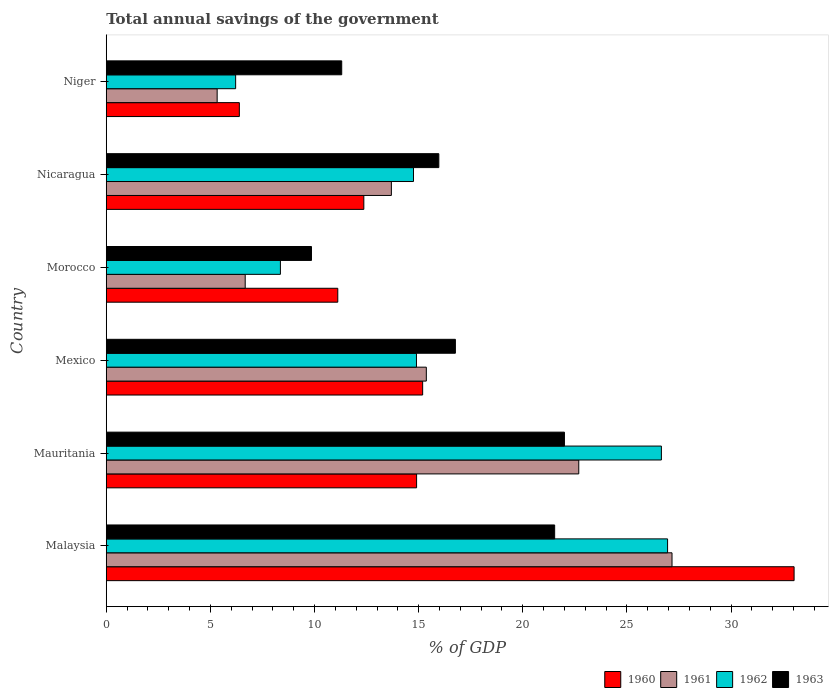How many different coloured bars are there?
Provide a succinct answer. 4. Are the number of bars per tick equal to the number of legend labels?
Make the answer very short. Yes. How many bars are there on the 4th tick from the bottom?
Offer a very short reply. 4. What is the label of the 6th group of bars from the top?
Your response must be concise. Malaysia. In how many cases, is the number of bars for a given country not equal to the number of legend labels?
Provide a short and direct response. 0. What is the total annual savings of the government in 1963 in Mexico?
Your response must be concise. 16.76. Across all countries, what is the maximum total annual savings of the government in 1963?
Offer a very short reply. 22. Across all countries, what is the minimum total annual savings of the government in 1960?
Your answer should be compact. 6.39. In which country was the total annual savings of the government in 1963 maximum?
Your answer should be very brief. Mauritania. In which country was the total annual savings of the government in 1961 minimum?
Provide a succinct answer. Niger. What is the total total annual savings of the government in 1961 in the graph?
Give a very brief answer. 90.9. What is the difference between the total annual savings of the government in 1963 in Morocco and that in Niger?
Offer a very short reply. -1.45. What is the difference between the total annual savings of the government in 1960 in Morocco and the total annual savings of the government in 1963 in Niger?
Your response must be concise. -0.19. What is the average total annual savings of the government in 1960 per country?
Offer a very short reply. 15.5. What is the difference between the total annual savings of the government in 1962 and total annual savings of the government in 1961 in Morocco?
Keep it short and to the point. 1.69. In how many countries, is the total annual savings of the government in 1963 greater than 5 %?
Your answer should be very brief. 6. What is the ratio of the total annual savings of the government in 1962 in Malaysia to that in Mauritania?
Ensure brevity in your answer.  1.01. What is the difference between the highest and the second highest total annual savings of the government in 1962?
Your answer should be very brief. 0.3. What is the difference between the highest and the lowest total annual savings of the government in 1961?
Your answer should be compact. 21.84. In how many countries, is the total annual savings of the government in 1960 greater than the average total annual savings of the government in 1960 taken over all countries?
Your response must be concise. 1. Is the sum of the total annual savings of the government in 1960 in Mauritania and Niger greater than the maximum total annual savings of the government in 1962 across all countries?
Offer a very short reply. No. What does the 4th bar from the top in Malaysia represents?
Keep it short and to the point. 1960. What does the 2nd bar from the bottom in Malaysia represents?
Provide a succinct answer. 1961. How many bars are there?
Ensure brevity in your answer.  24. Are all the bars in the graph horizontal?
Keep it short and to the point. Yes. What is the difference between two consecutive major ticks on the X-axis?
Your response must be concise. 5. Does the graph contain any zero values?
Your response must be concise. No. Does the graph contain grids?
Give a very brief answer. No. How many legend labels are there?
Make the answer very short. 4. How are the legend labels stacked?
Your response must be concise. Horizontal. What is the title of the graph?
Offer a very short reply. Total annual savings of the government. What is the label or title of the X-axis?
Offer a terse response. % of GDP. What is the label or title of the Y-axis?
Keep it short and to the point. Country. What is the % of GDP of 1960 in Malaysia?
Offer a terse response. 33.03. What is the % of GDP in 1961 in Malaysia?
Your response must be concise. 27.16. What is the % of GDP in 1962 in Malaysia?
Make the answer very short. 26.95. What is the % of GDP in 1963 in Malaysia?
Offer a terse response. 21.53. What is the % of GDP of 1960 in Mauritania?
Your answer should be very brief. 14.9. What is the % of GDP of 1961 in Mauritania?
Offer a very short reply. 22.69. What is the % of GDP of 1962 in Mauritania?
Your answer should be compact. 26.65. What is the % of GDP in 1963 in Mauritania?
Keep it short and to the point. 22. What is the % of GDP in 1960 in Mexico?
Offer a terse response. 15.19. What is the % of GDP in 1961 in Mexico?
Ensure brevity in your answer.  15.37. What is the % of GDP in 1962 in Mexico?
Keep it short and to the point. 14.89. What is the % of GDP of 1963 in Mexico?
Your answer should be compact. 16.76. What is the % of GDP of 1960 in Morocco?
Keep it short and to the point. 11.12. What is the % of GDP of 1961 in Morocco?
Give a very brief answer. 6.67. What is the % of GDP of 1962 in Morocco?
Your answer should be very brief. 8.36. What is the % of GDP of 1963 in Morocco?
Keep it short and to the point. 9.85. What is the % of GDP of 1960 in Nicaragua?
Your answer should be very brief. 12.37. What is the % of GDP in 1961 in Nicaragua?
Offer a terse response. 13.69. What is the % of GDP of 1962 in Nicaragua?
Provide a short and direct response. 14.75. What is the % of GDP in 1963 in Nicaragua?
Give a very brief answer. 15.97. What is the % of GDP in 1960 in Niger?
Offer a very short reply. 6.39. What is the % of GDP in 1961 in Niger?
Offer a terse response. 5.32. What is the % of GDP of 1962 in Niger?
Keep it short and to the point. 6.21. What is the % of GDP of 1963 in Niger?
Your answer should be very brief. 11.31. Across all countries, what is the maximum % of GDP of 1960?
Give a very brief answer. 33.03. Across all countries, what is the maximum % of GDP of 1961?
Your answer should be very brief. 27.16. Across all countries, what is the maximum % of GDP in 1962?
Offer a very short reply. 26.95. Across all countries, what is the maximum % of GDP in 1963?
Your answer should be compact. 22. Across all countries, what is the minimum % of GDP in 1960?
Make the answer very short. 6.39. Across all countries, what is the minimum % of GDP in 1961?
Make the answer very short. 5.32. Across all countries, what is the minimum % of GDP in 1962?
Offer a very short reply. 6.21. Across all countries, what is the minimum % of GDP of 1963?
Your response must be concise. 9.85. What is the total % of GDP of 1960 in the graph?
Provide a short and direct response. 92.99. What is the total % of GDP in 1961 in the graph?
Make the answer very short. 90.9. What is the total % of GDP in 1962 in the graph?
Your answer should be very brief. 97.83. What is the total % of GDP of 1963 in the graph?
Make the answer very short. 97.42. What is the difference between the % of GDP in 1960 in Malaysia and that in Mauritania?
Provide a succinct answer. 18.13. What is the difference between the % of GDP of 1961 in Malaysia and that in Mauritania?
Provide a succinct answer. 4.48. What is the difference between the % of GDP of 1962 in Malaysia and that in Mauritania?
Provide a short and direct response. 0.3. What is the difference between the % of GDP in 1963 in Malaysia and that in Mauritania?
Keep it short and to the point. -0.47. What is the difference between the % of GDP of 1960 in Malaysia and that in Mexico?
Provide a short and direct response. 17.83. What is the difference between the % of GDP in 1961 in Malaysia and that in Mexico?
Your answer should be compact. 11.8. What is the difference between the % of GDP of 1962 in Malaysia and that in Mexico?
Provide a short and direct response. 12.06. What is the difference between the % of GDP of 1963 in Malaysia and that in Mexico?
Keep it short and to the point. 4.77. What is the difference between the % of GDP of 1960 in Malaysia and that in Morocco?
Offer a very short reply. 21.91. What is the difference between the % of GDP in 1961 in Malaysia and that in Morocco?
Keep it short and to the point. 20.49. What is the difference between the % of GDP of 1962 in Malaysia and that in Morocco?
Make the answer very short. 18.59. What is the difference between the % of GDP in 1963 in Malaysia and that in Morocco?
Offer a terse response. 11.68. What is the difference between the % of GDP in 1960 in Malaysia and that in Nicaragua?
Offer a very short reply. 20.66. What is the difference between the % of GDP of 1961 in Malaysia and that in Nicaragua?
Provide a short and direct response. 13.47. What is the difference between the % of GDP of 1962 in Malaysia and that in Nicaragua?
Your answer should be very brief. 12.2. What is the difference between the % of GDP of 1963 in Malaysia and that in Nicaragua?
Keep it short and to the point. 5.56. What is the difference between the % of GDP in 1960 in Malaysia and that in Niger?
Your answer should be very brief. 26.63. What is the difference between the % of GDP of 1961 in Malaysia and that in Niger?
Ensure brevity in your answer.  21.84. What is the difference between the % of GDP in 1962 in Malaysia and that in Niger?
Your answer should be very brief. 20.74. What is the difference between the % of GDP of 1963 in Malaysia and that in Niger?
Offer a terse response. 10.22. What is the difference between the % of GDP of 1960 in Mauritania and that in Mexico?
Your response must be concise. -0.29. What is the difference between the % of GDP in 1961 in Mauritania and that in Mexico?
Provide a short and direct response. 7.32. What is the difference between the % of GDP in 1962 in Mauritania and that in Mexico?
Your response must be concise. 11.76. What is the difference between the % of GDP of 1963 in Mauritania and that in Mexico?
Make the answer very short. 5.24. What is the difference between the % of GDP in 1960 in Mauritania and that in Morocco?
Your answer should be compact. 3.78. What is the difference between the % of GDP of 1961 in Mauritania and that in Morocco?
Your answer should be very brief. 16.02. What is the difference between the % of GDP of 1962 in Mauritania and that in Morocco?
Offer a very short reply. 18.29. What is the difference between the % of GDP in 1963 in Mauritania and that in Morocco?
Offer a terse response. 12.14. What is the difference between the % of GDP of 1960 in Mauritania and that in Nicaragua?
Provide a short and direct response. 2.53. What is the difference between the % of GDP in 1961 in Mauritania and that in Nicaragua?
Ensure brevity in your answer.  9. What is the difference between the % of GDP of 1962 in Mauritania and that in Nicaragua?
Keep it short and to the point. 11.9. What is the difference between the % of GDP of 1963 in Mauritania and that in Nicaragua?
Ensure brevity in your answer.  6.03. What is the difference between the % of GDP in 1960 in Mauritania and that in Niger?
Make the answer very short. 8.51. What is the difference between the % of GDP in 1961 in Mauritania and that in Niger?
Your answer should be very brief. 17.36. What is the difference between the % of GDP in 1962 in Mauritania and that in Niger?
Provide a succinct answer. 20.44. What is the difference between the % of GDP in 1963 in Mauritania and that in Niger?
Your answer should be compact. 10.69. What is the difference between the % of GDP in 1960 in Mexico and that in Morocco?
Your response must be concise. 4.08. What is the difference between the % of GDP of 1961 in Mexico and that in Morocco?
Keep it short and to the point. 8.7. What is the difference between the % of GDP in 1962 in Mexico and that in Morocco?
Your answer should be very brief. 6.53. What is the difference between the % of GDP in 1963 in Mexico and that in Morocco?
Ensure brevity in your answer.  6.91. What is the difference between the % of GDP of 1960 in Mexico and that in Nicaragua?
Offer a very short reply. 2.82. What is the difference between the % of GDP of 1961 in Mexico and that in Nicaragua?
Keep it short and to the point. 1.68. What is the difference between the % of GDP in 1962 in Mexico and that in Nicaragua?
Give a very brief answer. 0.14. What is the difference between the % of GDP in 1963 in Mexico and that in Nicaragua?
Provide a succinct answer. 0.8. What is the difference between the % of GDP of 1960 in Mexico and that in Niger?
Offer a very short reply. 8.8. What is the difference between the % of GDP of 1961 in Mexico and that in Niger?
Keep it short and to the point. 10.04. What is the difference between the % of GDP of 1962 in Mexico and that in Niger?
Offer a terse response. 8.68. What is the difference between the % of GDP in 1963 in Mexico and that in Niger?
Offer a terse response. 5.46. What is the difference between the % of GDP in 1960 in Morocco and that in Nicaragua?
Provide a succinct answer. -1.25. What is the difference between the % of GDP in 1961 in Morocco and that in Nicaragua?
Your answer should be compact. -7.02. What is the difference between the % of GDP in 1962 in Morocco and that in Nicaragua?
Keep it short and to the point. -6.39. What is the difference between the % of GDP of 1963 in Morocco and that in Nicaragua?
Make the answer very short. -6.11. What is the difference between the % of GDP in 1960 in Morocco and that in Niger?
Offer a terse response. 4.73. What is the difference between the % of GDP in 1961 in Morocco and that in Niger?
Offer a very short reply. 1.35. What is the difference between the % of GDP of 1962 in Morocco and that in Niger?
Ensure brevity in your answer.  2.15. What is the difference between the % of GDP of 1963 in Morocco and that in Niger?
Give a very brief answer. -1.45. What is the difference between the % of GDP in 1960 in Nicaragua and that in Niger?
Offer a very short reply. 5.98. What is the difference between the % of GDP in 1961 in Nicaragua and that in Niger?
Give a very brief answer. 8.37. What is the difference between the % of GDP of 1962 in Nicaragua and that in Niger?
Your answer should be compact. 8.54. What is the difference between the % of GDP in 1963 in Nicaragua and that in Niger?
Your response must be concise. 4.66. What is the difference between the % of GDP in 1960 in Malaysia and the % of GDP in 1961 in Mauritania?
Offer a terse response. 10.34. What is the difference between the % of GDP of 1960 in Malaysia and the % of GDP of 1962 in Mauritania?
Your response must be concise. 6.37. What is the difference between the % of GDP in 1960 in Malaysia and the % of GDP in 1963 in Mauritania?
Offer a very short reply. 11.03. What is the difference between the % of GDP of 1961 in Malaysia and the % of GDP of 1962 in Mauritania?
Offer a very short reply. 0.51. What is the difference between the % of GDP of 1961 in Malaysia and the % of GDP of 1963 in Mauritania?
Give a very brief answer. 5.17. What is the difference between the % of GDP of 1962 in Malaysia and the % of GDP of 1963 in Mauritania?
Provide a short and direct response. 4.95. What is the difference between the % of GDP in 1960 in Malaysia and the % of GDP in 1961 in Mexico?
Your response must be concise. 17.66. What is the difference between the % of GDP in 1960 in Malaysia and the % of GDP in 1962 in Mexico?
Provide a succinct answer. 18.13. What is the difference between the % of GDP in 1960 in Malaysia and the % of GDP in 1963 in Mexico?
Your answer should be compact. 16.26. What is the difference between the % of GDP in 1961 in Malaysia and the % of GDP in 1962 in Mexico?
Your answer should be very brief. 12.27. What is the difference between the % of GDP of 1961 in Malaysia and the % of GDP of 1963 in Mexico?
Offer a terse response. 10.4. What is the difference between the % of GDP in 1962 in Malaysia and the % of GDP in 1963 in Mexico?
Give a very brief answer. 10.19. What is the difference between the % of GDP in 1960 in Malaysia and the % of GDP in 1961 in Morocco?
Your response must be concise. 26.35. What is the difference between the % of GDP of 1960 in Malaysia and the % of GDP of 1962 in Morocco?
Your response must be concise. 24.66. What is the difference between the % of GDP of 1960 in Malaysia and the % of GDP of 1963 in Morocco?
Your response must be concise. 23.17. What is the difference between the % of GDP of 1961 in Malaysia and the % of GDP of 1962 in Morocco?
Your response must be concise. 18.8. What is the difference between the % of GDP in 1961 in Malaysia and the % of GDP in 1963 in Morocco?
Provide a short and direct response. 17.31. What is the difference between the % of GDP in 1962 in Malaysia and the % of GDP in 1963 in Morocco?
Your answer should be very brief. 17.1. What is the difference between the % of GDP of 1960 in Malaysia and the % of GDP of 1961 in Nicaragua?
Give a very brief answer. 19.34. What is the difference between the % of GDP of 1960 in Malaysia and the % of GDP of 1962 in Nicaragua?
Provide a short and direct response. 18.27. What is the difference between the % of GDP in 1960 in Malaysia and the % of GDP in 1963 in Nicaragua?
Keep it short and to the point. 17.06. What is the difference between the % of GDP in 1961 in Malaysia and the % of GDP in 1962 in Nicaragua?
Your answer should be very brief. 12.41. What is the difference between the % of GDP in 1961 in Malaysia and the % of GDP in 1963 in Nicaragua?
Make the answer very short. 11.2. What is the difference between the % of GDP of 1962 in Malaysia and the % of GDP of 1963 in Nicaragua?
Provide a succinct answer. 10.98. What is the difference between the % of GDP of 1960 in Malaysia and the % of GDP of 1961 in Niger?
Offer a very short reply. 27.7. What is the difference between the % of GDP of 1960 in Malaysia and the % of GDP of 1962 in Niger?
Offer a terse response. 26.81. What is the difference between the % of GDP of 1960 in Malaysia and the % of GDP of 1963 in Niger?
Offer a terse response. 21.72. What is the difference between the % of GDP of 1961 in Malaysia and the % of GDP of 1962 in Niger?
Provide a succinct answer. 20.95. What is the difference between the % of GDP in 1961 in Malaysia and the % of GDP in 1963 in Niger?
Provide a short and direct response. 15.86. What is the difference between the % of GDP of 1962 in Malaysia and the % of GDP of 1963 in Niger?
Give a very brief answer. 15.65. What is the difference between the % of GDP in 1960 in Mauritania and the % of GDP in 1961 in Mexico?
Ensure brevity in your answer.  -0.47. What is the difference between the % of GDP of 1960 in Mauritania and the % of GDP of 1962 in Mexico?
Make the answer very short. 0.01. What is the difference between the % of GDP in 1960 in Mauritania and the % of GDP in 1963 in Mexico?
Ensure brevity in your answer.  -1.86. What is the difference between the % of GDP in 1961 in Mauritania and the % of GDP in 1962 in Mexico?
Keep it short and to the point. 7.79. What is the difference between the % of GDP of 1961 in Mauritania and the % of GDP of 1963 in Mexico?
Your response must be concise. 5.92. What is the difference between the % of GDP of 1962 in Mauritania and the % of GDP of 1963 in Mexico?
Your answer should be very brief. 9.89. What is the difference between the % of GDP of 1960 in Mauritania and the % of GDP of 1961 in Morocco?
Offer a terse response. 8.23. What is the difference between the % of GDP in 1960 in Mauritania and the % of GDP in 1962 in Morocco?
Ensure brevity in your answer.  6.54. What is the difference between the % of GDP of 1960 in Mauritania and the % of GDP of 1963 in Morocco?
Keep it short and to the point. 5.05. What is the difference between the % of GDP in 1961 in Mauritania and the % of GDP in 1962 in Morocco?
Ensure brevity in your answer.  14.32. What is the difference between the % of GDP in 1961 in Mauritania and the % of GDP in 1963 in Morocco?
Offer a terse response. 12.83. What is the difference between the % of GDP of 1962 in Mauritania and the % of GDP of 1963 in Morocco?
Ensure brevity in your answer.  16.8. What is the difference between the % of GDP of 1960 in Mauritania and the % of GDP of 1961 in Nicaragua?
Provide a succinct answer. 1.21. What is the difference between the % of GDP of 1960 in Mauritania and the % of GDP of 1962 in Nicaragua?
Provide a short and direct response. 0.15. What is the difference between the % of GDP in 1960 in Mauritania and the % of GDP in 1963 in Nicaragua?
Offer a terse response. -1.07. What is the difference between the % of GDP of 1961 in Mauritania and the % of GDP of 1962 in Nicaragua?
Keep it short and to the point. 7.93. What is the difference between the % of GDP of 1961 in Mauritania and the % of GDP of 1963 in Nicaragua?
Offer a very short reply. 6.72. What is the difference between the % of GDP of 1962 in Mauritania and the % of GDP of 1963 in Nicaragua?
Make the answer very short. 10.69. What is the difference between the % of GDP of 1960 in Mauritania and the % of GDP of 1961 in Niger?
Your answer should be very brief. 9.58. What is the difference between the % of GDP in 1960 in Mauritania and the % of GDP in 1962 in Niger?
Keep it short and to the point. 8.69. What is the difference between the % of GDP of 1960 in Mauritania and the % of GDP of 1963 in Niger?
Keep it short and to the point. 3.6. What is the difference between the % of GDP in 1961 in Mauritania and the % of GDP in 1962 in Niger?
Ensure brevity in your answer.  16.47. What is the difference between the % of GDP of 1961 in Mauritania and the % of GDP of 1963 in Niger?
Your answer should be compact. 11.38. What is the difference between the % of GDP of 1962 in Mauritania and the % of GDP of 1963 in Niger?
Keep it short and to the point. 15.35. What is the difference between the % of GDP of 1960 in Mexico and the % of GDP of 1961 in Morocco?
Your answer should be very brief. 8.52. What is the difference between the % of GDP of 1960 in Mexico and the % of GDP of 1962 in Morocco?
Provide a succinct answer. 6.83. What is the difference between the % of GDP in 1960 in Mexico and the % of GDP in 1963 in Morocco?
Offer a very short reply. 5.34. What is the difference between the % of GDP of 1961 in Mexico and the % of GDP of 1962 in Morocco?
Your response must be concise. 7.01. What is the difference between the % of GDP in 1961 in Mexico and the % of GDP in 1963 in Morocco?
Your answer should be compact. 5.51. What is the difference between the % of GDP in 1962 in Mexico and the % of GDP in 1963 in Morocco?
Give a very brief answer. 5.04. What is the difference between the % of GDP in 1960 in Mexico and the % of GDP in 1961 in Nicaragua?
Provide a short and direct response. 1.5. What is the difference between the % of GDP in 1960 in Mexico and the % of GDP in 1962 in Nicaragua?
Provide a short and direct response. 0.44. What is the difference between the % of GDP in 1960 in Mexico and the % of GDP in 1963 in Nicaragua?
Offer a terse response. -0.78. What is the difference between the % of GDP of 1961 in Mexico and the % of GDP of 1962 in Nicaragua?
Your answer should be very brief. 0.62. What is the difference between the % of GDP of 1961 in Mexico and the % of GDP of 1963 in Nicaragua?
Make the answer very short. -0.6. What is the difference between the % of GDP in 1962 in Mexico and the % of GDP in 1963 in Nicaragua?
Make the answer very short. -1.07. What is the difference between the % of GDP in 1960 in Mexico and the % of GDP in 1961 in Niger?
Give a very brief answer. 9.87. What is the difference between the % of GDP of 1960 in Mexico and the % of GDP of 1962 in Niger?
Your response must be concise. 8.98. What is the difference between the % of GDP in 1960 in Mexico and the % of GDP in 1963 in Niger?
Keep it short and to the point. 3.89. What is the difference between the % of GDP in 1961 in Mexico and the % of GDP in 1962 in Niger?
Your response must be concise. 9.16. What is the difference between the % of GDP of 1961 in Mexico and the % of GDP of 1963 in Niger?
Keep it short and to the point. 4.06. What is the difference between the % of GDP in 1962 in Mexico and the % of GDP in 1963 in Niger?
Offer a very short reply. 3.59. What is the difference between the % of GDP of 1960 in Morocco and the % of GDP of 1961 in Nicaragua?
Ensure brevity in your answer.  -2.57. What is the difference between the % of GDP of 1960 in Morocco and the % of GDP of 1962 in Nicaragua?
Your answer should be compact. -3.63. What is the difference between the % of GDP of 1960 in Morocco and the % of GDP of 1963 in Nicaragua?
Your answer should be compact. -4.85. What is the difference between the % of GDP in 1961 in Morocco and the % of GDP in 1962 in Nicaragua?
Ensure brevity in your answer.  -8.08. What is the difference between the % of GDP in 1961 in Morocco and the % of GDP in 1963 in Nicaragua?
Offer a very short reply. -9.3. What is the difference between the % of GDP of 1962 in Morocco and the % of GDP of 1963 in Nicaragua?
Make the answer very short. -7.61. What is the difference between the % of GDP in 1960 in Morocco and the % of GDP in 1961 in Niger?
Keep it short and to the point. 5.79. What is the difference between the % of GDP of 1960 in Morocco and the % of GDP of 1962 in Niger?
Offer a very short reply. 4.9. What is the difference between the % of GDP of 1960 in Morocco and the % of GDP of 1963 in Niger?
Make the answer very short. -0.19. What is the difference between the % of GDP in 1961 in Morocco and the % of GDP in 1962 in Niger?
Offer a very short reply. 0.46. What is the difference between the % of GDP of 1961 in Morocco and the % of GDP of 1963 in Niger?
Your answer should be compact. -4.63. What is the difference between the % of GDP of 1962 in Morocco and the % of GDP of 1963 in Niger?
Your answer should be very brief. -2.94. What is the difference between the % of GDP in 1960 in Nicaragua and the % of GDP in 1961 in Niger?
Offer a very short reply. 7.04. What is the difference between the % of GDP of 1960 in Nicaragua and the % of GDP of 1962 in Niger?
Your response must be concise. 6.16. What is the difference between the % of GDP of 1960 in Nicaragua and the % of GDP of 1963 in Niger?
Keep it short and to the point. 1.06. What is the difference between the % of GDP in 1961 in Nicaragua and the % of GDP in 1962 in Niger?
Offer a terse response. 7.48. What is the difference between the % of GDP in 1961 in Nicaragua and the % of GDP in 1963 in Niger?
Offer a terse response. 2.38. What is the difference between the % of GDP in 1962 in Nicaragua and the % of GDP in 1963 in Niger?
Provide a short and direct response. 3.45. What is the average % of GDP of 1960 per country?
Your answer should be compact. 15.5. What is the average % of GDP of 1961 per country?
Your response must be concise. 15.15. What is the average % of GDP in 1962 per country?
Offer a very short reply. 16.3. What is the average % of GDP in 1963 per country?
Provide a succinct answer. 16.24. What is the difference between the % of GDP of 1960 and % of GDP of 1961 in Malaysia?
Make the answer very short. 5.86. What is the difference between the % of GDP of 1960 and % of GDP of 1962 in Malaysia?
Give a very brief answer. 6.07. What is the difference between the % of GDP in 1960 and % of GDP in 1963 in Malaysia?
Your response must be concise. 11.5. What is the difference between the % of GDP in 1961 and % of GDP in 1962 in Malaysia?
Your answer should be compact. 0.21. What is the difference between the % of GDP of 1961 and % of GDP of 1963 in Malaysia?
Provide a succinct answer. 5.63. What is the difference between the % of GDP in 1962 and % of GDP in 1963 in Malaysia?
Ensure brevity in your answer.  5.42. What is the difference between the % of GDP in 1960 and % of GDP in 1961 in Mauritania?
Offer a terse response. -7.79. What is the difference between the % of GDP in 1960 and % of GDP in 1962 in Mauritania?
Your answer should be very brief. -11.75. What is the difference between the % of GDP in 1960 and % of GDP in 1963 in Mauritania?
Provide a short and direct response. -7.1. What is the difference between the % of GDP of 1961 and % of GDP of 1962 in Mauritania?
Give a very brief answer. -3.97. What is the difference between the % of GDP in 1961 and % of GDP in 1963 in Mauritania?
Your answer should be compact. 0.69. What is the difference between the % of GDP in 1962 and % of GDP in 1963 in Mauritania?
Your response must be concise. 4.66. What is the difference between the % of GDP in 1960 and % of GDP in 1961 in Mexico?
Offer a terse response. -0.18. What is the difference between the % of GDP of 1960 and % of GDP of 1962 in Mexico?
Offer a terse response. 0.3. What is the difference between the % of GDP of 1960 and % of GDP of 1963 in Mexico?
Your response must be concise. -1.57. What is the difference between the % of GDP of 1961 and % of GDP of 1962 in Mexico?
Your response must be concise. 0.47. What is the difference between the % of GDP of 1961 and % of GDP of 1963 in Mexico?
Offer a very short reply. -1.4. What is the difference between the % of GDP in 1962 and % of GDP in 1963 in Mexico?
Keep it short and to the point. -1.87. What is the difference between the % of GDP in 1960 and % of GDP in 1961 in Morocco?
Offer a terse response. 4.45. What is the difference between the % of GDP of 1960 and % of GDP of 1962 in Morocco?
Ensure brevity in your answer.  2.75. What is the difference between the % of GDP of 1960 and % of GDP of 1963 in Morocco?
Ensure brevity in your answer.  1.26. What is the difference between the % of GDP in 1961 and % of GDP in 1962 in Morocco?
Your answer should be very brief. -1.69. What is the difference between the % of GDP of 1961 and % of GDP of 1963 in Morocco?
Make the answer very short. -3.18. What is the difference between the % of GDP of 1962 and % of GDP of 1963 in Morocco?
Make the answer very short. -1.49. What is the difference between the % of GDP of 1960 and % of GDP of 1961 in Nicaragua?
Keep it short and to the point. -1.32. What is the difference between the % of GDP of 1960 and % of GDP of 1962 in Nicaragua?
Your response must be concise. -2.38. What is the difference between the % of GDP of 1960 and % of GDP of 1963 in Nicaragua?
Provide a succinct answer. -3.6. What is the difference between the % of GDP in 1961 and % of GDP in 1962 in Nicaragua?
Your answer should be very brief. -1.06. What is the difference between the % of GDP of 1961 and % of GDP of 1963 in Nicaragua?
Provide a short and direct response. -2.28. What is the difference between the % of GDP in 1962 and % of GDP in 1963 in Nicaragua?
Make the answer very short. -1.22. What is the difference between the % of GDP in 1960 and % of GDP in 1961 in Niger?
Provide a short and direct response. 1.07. What is the difference between the % of GDP of 1960 and % of GDP of 1962 in Niger?
Ensure brevity in your answer.  0.18. What is the difference between the % of GDP of 1960 and % of GDP of 1963 in Niger?
Keep it short and to the point. -4.91. What is the difference between the % of GDP in 1961 and % of GDP in 1962 in Niger?
Provide a succinct answer. -0.89. What is the difference between the % of GDP of 1961 and % of GDP of 1963 in Niger?
Make the answer very short. -5.98. What is the difference between the % of GDP in 1962 and % of GDP in 1963 in Niger?
Offer a terse response. -5.09. What is the ratio of the % of GDP in 1960 in Malaysia to that in Mauritania?
Your answer should be compact. 2.22. What is the ratio of the % of GDP of 1961 in Malaysia to that in Mauritania?
Provide a short and direct response. 1.2. What is the ratio of the % of GDP in 1962 in Malaysia to that in Mauritania?
Your answer should be very brief. 1.01. What is the ratio of the % of GDP in 1963 in Malaysia to that in Mauritania?
Ensure brevity in your answer.  0.98. What is the ratio of the % of GDP of 1960 in Malaysia to that in Mexico?
Provide a short and direct response. 2.17. What is the ratio of the % of GDP of 1961 in Malaysia to that in Mexico?
Offer a terse response. 1.77. What is the ratio of the % of GDP in 1962 in Malaysia to that in Mexico?
Your answer should be very brief. 1.81. What is the ratio of the % of GDP in 1963 in Malaysia to that in Mexico?
Provide a short and direct response. 1.28. What is the ratio of the % of GDP of 1960 in Malaysia to that in Morocco?
Your answer should be compact. 2.97. What is the ratio of the % of GDP in 1961 in Malaysia to that in Morocco?
Give a very brief answer. 4.07. What is the ratio of the % of GDP of 1962 in Malaysia to that in Morocco?
Your answer should be compact. 3.22. What is the ratio of the % of GDP of 1963 in Malaysia to that in Morocco?
Offer a terse response. 2.18. What is the ratio of the % of GDP in 1960 in Malaysia to that in Nicaragua?
Keep it short and to the point. 2.67. What is the ratio of the % of GDP in 1961 in Malaysia to that in Nicaragua?
Give a very brief answer. 1.98. What is the ratio of the % of GDP in 1962 in Malaysia to that in Nicaragua?
Offer a terse response. 1.83. What is the ratio of the % of GDP in 1963 in Malaysia to that in Nicaragua?
Offer a terse response. 1.35. What is the ratio of the % of GDP of 1960 in Malaysia to that in Niger?
Provide a short and direct response. 5.17. What is the ratio of the % of GDP in 1961 in Malaysia to that in Niger?
Provide a succinct answer. 5.1. What is the ratio of the % of GDP of 1962 in Malaysia to that in Niger?
Keep it short and to the point. 4.34. What is the ratio of the % of GDP in 1963 in Malaysia to that in Niger?
Your response must be concise. 1.9. What is the ratio of the % of GDP of 1960 in Mauritania to that in Mexico?
Ensure brevity in your answer.  0.98. What is the ratio of the % of GDP of 1961 in Mauritania to that in Mexico?
Provide a succinct answer. 1.48. What is the ratio of the % of GDP in 1962 in Mauritania to that in Mexico?
Provide a succinct answer. 1.79. What is the ratio of the % of GDP of 1963 in Mauritania to that in Mexico?
Your answer should be compact. 1.31. What is the ratio of the % of GDP of 1960 in Mauritania to that in Morocco?
Your answer should be compact. 1.34. What is the ratio of the % of GDP of 1961 in Mauritania to that in Morocco?
Your answer should be compact. 3.4. What is the ratio of the % of GDP of 1962 in Mauritania to that in Morocco?
Give a very brief answer. 3.19. What is the ratio of the % of GDP in 1963 in Mauritania to that in Morocco?
Keep it short and to the point. 2.23. What is the ratio of the % of GDP of 1960 in Mauritania to that in Nicaragua?
Your answer should be compact. 1.2. What is the ratio of the % of GDP of 1961 in Mauritania to that in Nicaragua?
Your answer should be compact. 1.66. What is the ratio of the % of GDP of 1962 in Mauritania to that in Nicaragua?
Provide a short and direct response. 1.81. What is the ratio of the % of GDP in 1963 in Mauritania to that in Nicaragua?
Provide a succinct answer. 1.38. What is the ratio of the % of GDP in 1960 in Mauritania to that in Niger?
Your answer should be compact. 2.33. What is the ratio of the % of GDP of 1961 in Mauritania to that in Niger?
Offer a very short reply. 4.26. What is the ratio of the % of GDP of 1962 in Mauritania to that in Niger?
Provide a succinct answer. 4.29. What is the ratio of the % of GDP of 1963 in Mauritania to that in Niger?
Provide a short and direct response. 1.95. What is the ratio of the % of GDP of 1960 in Mexico to that in Morocco?
Offer a terse response. 1.37. What is the ratio of the % of GDP of 1961 in Mexico to that in Morocco?
Provide a short and direct response. 2.3. What is the ratio of the % of GDP in 1962 in Mexico to that in Morocco?
Your response must be concise. 1.78. What is the ratio of the % of GDP of 1963 in Mexico to that in Morocco?
Provide a short and direct response. 1.7. What is the ratio of the % of GDP in 1960 in Mexico to that in Nicaragua?
Offer a very short reply. 1.23. What is the ratio of the % of GDP of 1961 in Mexico to that in Nicaragua?
Keep it short and to the point. 1.12. What is the ratio of the % of GDP of 1962 in Mexico to that in Nicaragua?
Give a very brief answer. 1.01. What is the ratio of the % of GDP of 1963 in Mexico to that in Nicaragua?
Keep it short and to the point. 1.05. What is the ratio of the % of GDP in 1960 in Mexico to that in Niger?
Keep it short and to the point. 2.38. What is the ratio of the % of GDP in 1961 in Mexico to that in Niger?
Make the answer very short. 2.89. What is the ratio of the % of GDP of 1962 in Mexico to that in Niger?
Give a very brief answer. 2.4. What is the ratio of the % of GDP of 1963 in Mexico to that in Niger?
Offer a very short reply. 1.48. What is the ratio of the % of GDP of 1960 in Morocco to that in Nicaragua?
Make the answer very short. 0.9. What is the ratio of the % of GDP in 1961 in Morocco to that in Nicaragua?
Make the answer very short. 0.49. What is the ratio of the % of GDP of 1962 in Morocco to that in Nicaragua?
Ensure brevity in your answer.  0.57. What is the ratio of the % of GDP in 1963 in Morocco to that in Nicaragua?
Make the answer very short. 0.62. What is the ratio of the % of GDP of 1960 in Morocco to that in Niger?
Offer a terse response. 1.74. What is the ratio of the % of GDP in 1961 in Morocco to that in Niger?
Provide a succinct answer. 1.25. What is the ratio of the % of GDP of 1962 in Morocco to that in Niger?
Provide a succinct answer. 1.35. What is the ratio of the % of GDP of 1963 in Morocco to that in Niger?
Your answer should be very brief. 0.87. What is the ratio of the % of GDP of 1960 in Nicaragua to that in Niger?
Give a very brief answer. 1.94. What is the ratio of the % of GDP in 1961 in Nicaragua to that in Niger?
Ensure brevity in your answer.  2.57. What is the ratio of the % of GDP in 1962 in Nicaragua to that in Niger?
Make the answer very short. 2.37. What is the ratio of the % of GDP in 1963 in Nicaragua to that in Niger?
Keep it short and to the point. 1.41. What is the difference between the highest and the second highest % of GDP in 1960?
Your answer should be very brief. 17.83. What is the difference between the highest and the second highest % of GDP of 1961?
Offer a terse response. 4.48. What is the difference between the highest and the second highest % of GDP of 1962?
Keep it short and to the point. 0.3. What is the difference between the highest and the second highest % of GDP in 1963?
Your answer should be compact. 0.47. What is the difference between the highest and the lowest % of GDP of 1960?
Your answer should be compact. 26.63. What is the difference between the highest and the lowest % of GDP of 1961?
Offer a very short reply. 21.84. What is the difference between the highest and the lowest % of GDP of 1962?
Provide a succinct answer. 20.74. What is the difference between the highest and the lowest % of GDP of 1963?
Keep it short and to the point. 12.14. 